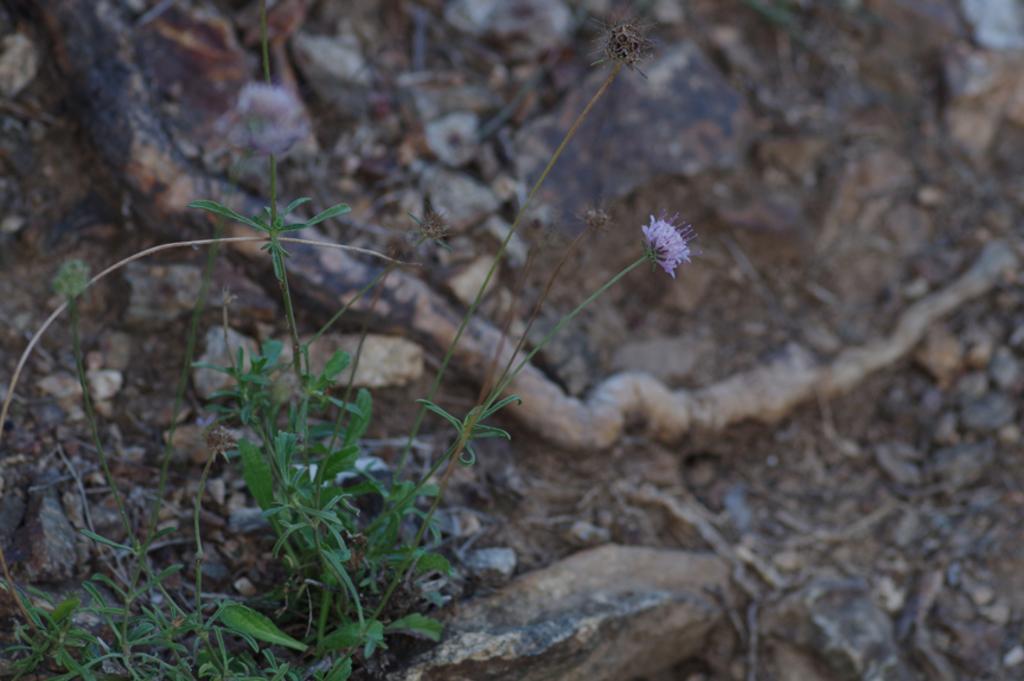Can you describe this image briefly? In this image we can see plants, flower and ground. 